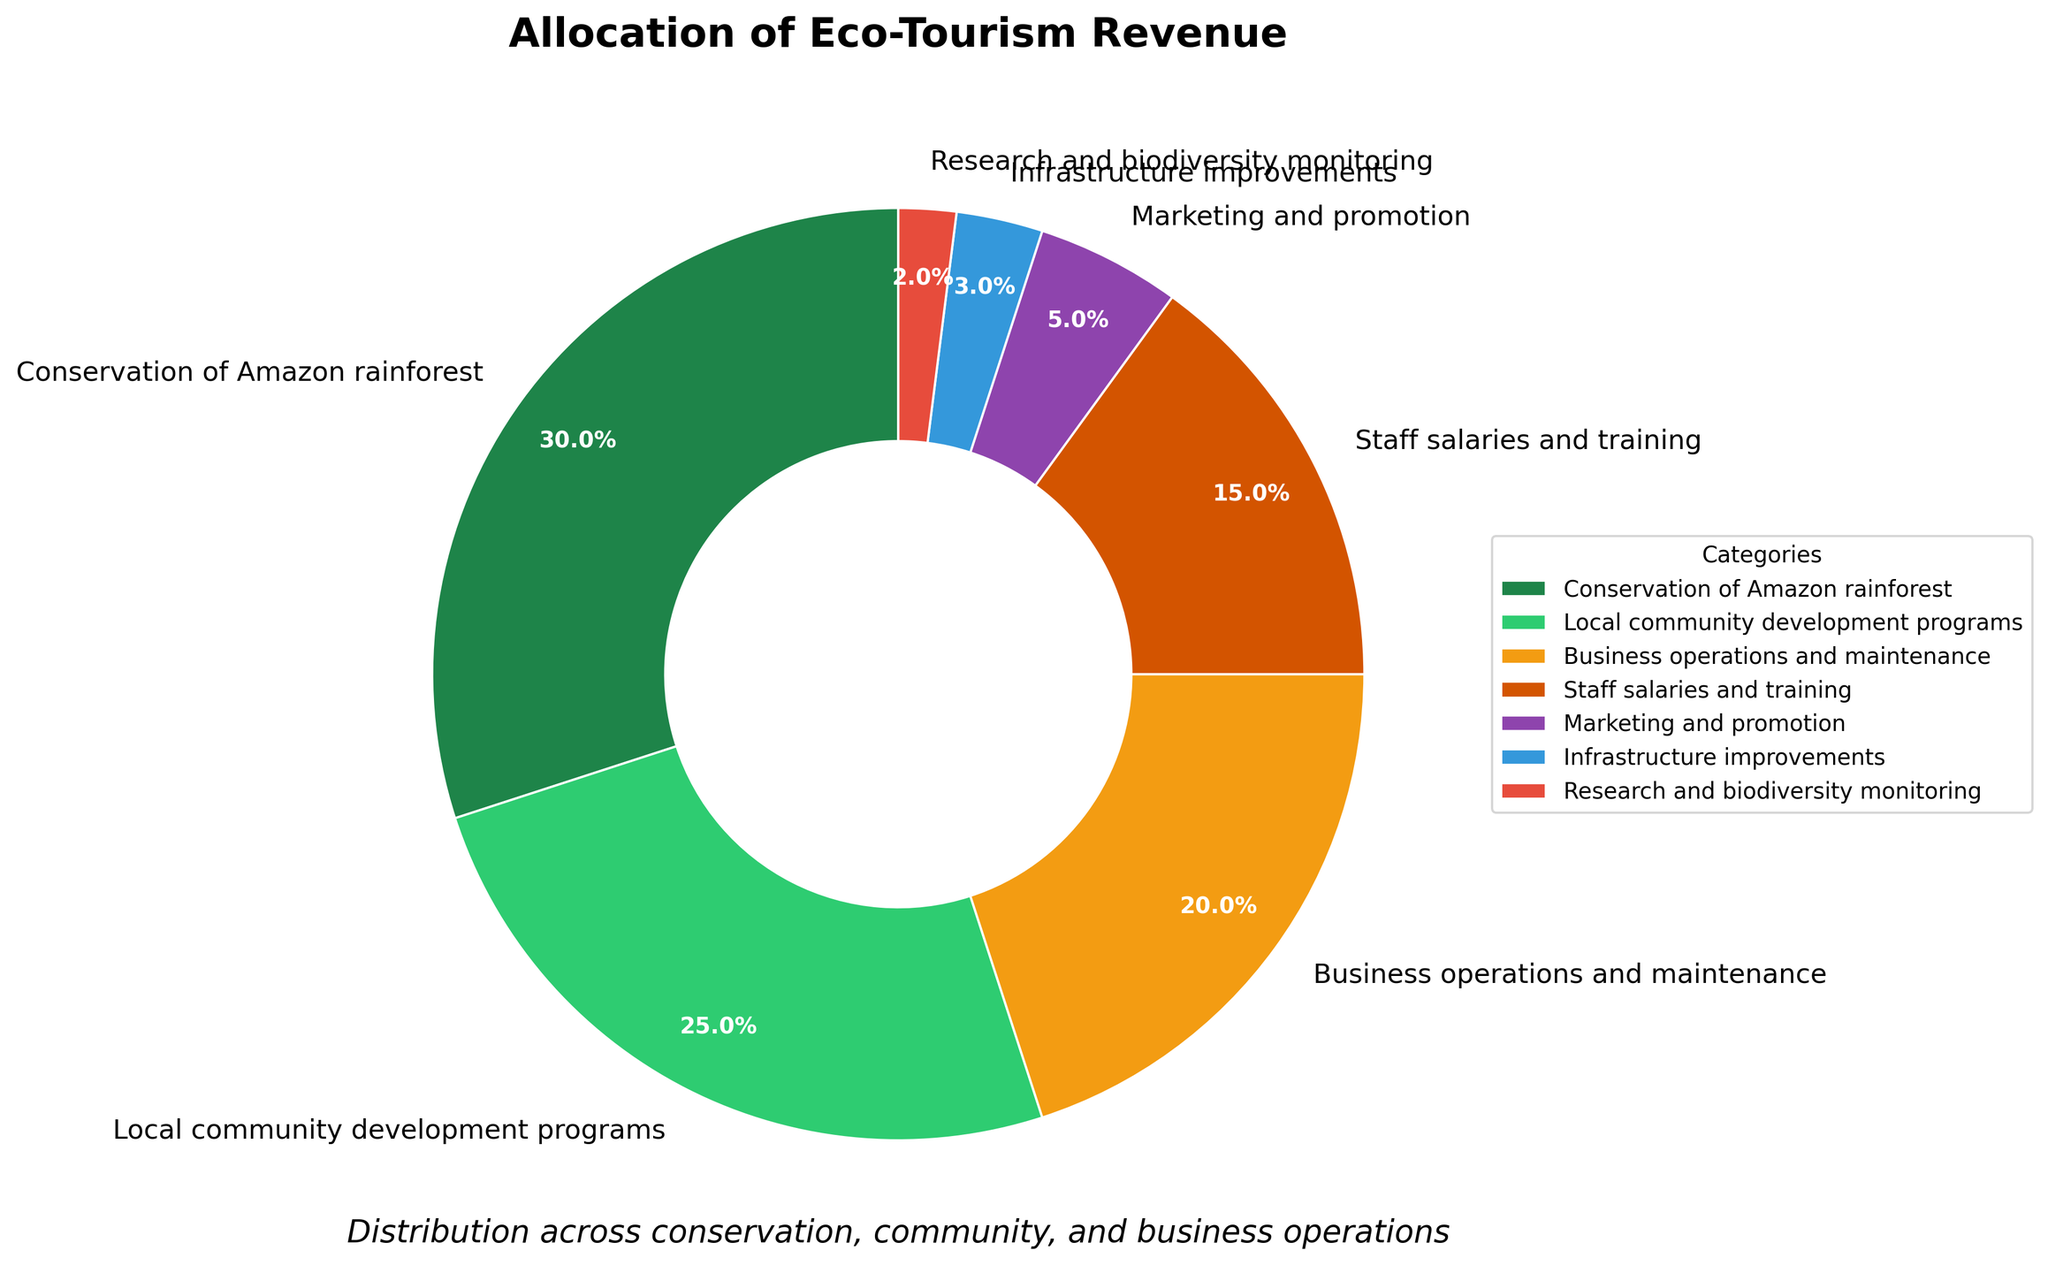What category receives the highest allocation of revenue? The pie chart shows percentages of revenue allocated to different categories. The largest portion is labeled "Conservation of Amazon rainforest" at 30%.
Answer: Conservation of Amazon rainforest How much more revenue is allocated to local community development programs compared to research and biodiversity monitoring? The percentage for local community development programs is 25%, and for research and biodiversity monitoring, it is 2%. The difference is 25% - 2% = 23%.
Answer: 23% What is the combined percentage of revenue allocated to business operations and marketing? The chart shows 20% for business operations and 5% for marketing and promotion. Adding these together (20% + 5%) results in 25%.
Answer: 25% Which category has the smallest allocation of revenue, and what is that percentage? The smallest section of the pie chart represents "Research and biodiversity monitoring," which receives 2% of the revenue.
Answer: Research and biodiversity monitoring, 2% Are the combined allocations for conservation and staff salaries greater than 50%? The chart shows 30% for conservation and 15% for staff salaries. Adding these together (30% + 15%) equals 45%, which is less than 50%.
Answer: No Which two categories together make up exactly 22% of the revenue allocation? The chart shows that infrastructure improvements receive 3% and research and biodiversity monitoring receive 2%, so these cannot be an answer. However, adding staff salaries (15%) and infrastructure improvements (3%) results in 18%, which also doesn't fit. Next, marketing and promotion (5%) and infrastructure improvements (3%) combined add to 8%. Nonetheless, business operations (20%) and research and biodiversity monitoring (2%) add up to exactly 22%.
Answer: Business operations and research and biodiversity monitoring How much revenue is allocated to efforts not directly related to conservation (i.e., community development, business operations, staff salaries, marketing, infrastructure, and research)? This involves summing up percentages for all categories except conservation. That's 25% + 20% + 15% + 5% + 3% + 2% = 70%.
Answer: 70% What percentage of revenue is allocated to business-related fields (business operations, staff salaries and training, marketing and promotion, infrastructure improvements)? We sum the percentages: business operations (20%), staff salaries (15%), marketing (5%), and infrastructure (3%). Adding these together (20% + 15% + 5% + 3%) gives 43%.
Answer: 43% Is the allocation for local community development programs more than double the allocation for marketing and promotion? The allocation for local community development programs is 25%, and for marketing and promotion, it is 5%. Since 25% is more than twice 5%, the answer is yes.
Answer: Yes 